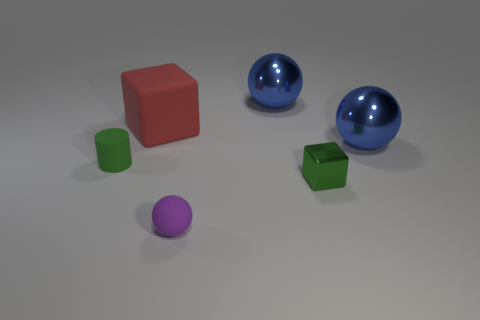Subtract all purple spheres. How many spheres are left? 2 Subtract all small purple balls. How many balls are left? 2 Subtract 1 cylinders. How many cylinders are left? 0 Subtract all cylinders. How many objects are left? 5 Subtract all purple cylinders. How many green blocks are left? 1 Add 3 small matte objects. How many objects exist? 9 Subtract 0 purple blocks. How many objects are left? 6 Subtract all yellow cylinders. Subtract all purple balls. How many cylinders are left? 1 Subtract all green blocks. Subtract all tiny green blocks. How many objects are left? 4 Add 4 cylinders. How many cylinders are left? 5 